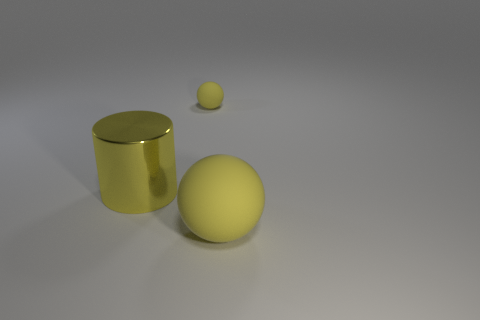Add 1 brown cubes. How many objects exist? 4 Subtract all spheres. How many objects are left? 1 Add 3 rubber things. How many rubber things are left? 5 Add 1 small cyan shiny cubes. How many small cyan shiny cubes exist? 1 Subtract 0 purple cylinders. How many objects are left? 3 Subtract all red spheres. Subtract all cyan cylinders. How many spheres are left? 2 Subtract all small cyan shiny balls. Subtract all big yellow cylinders. How many objects are left? 2 